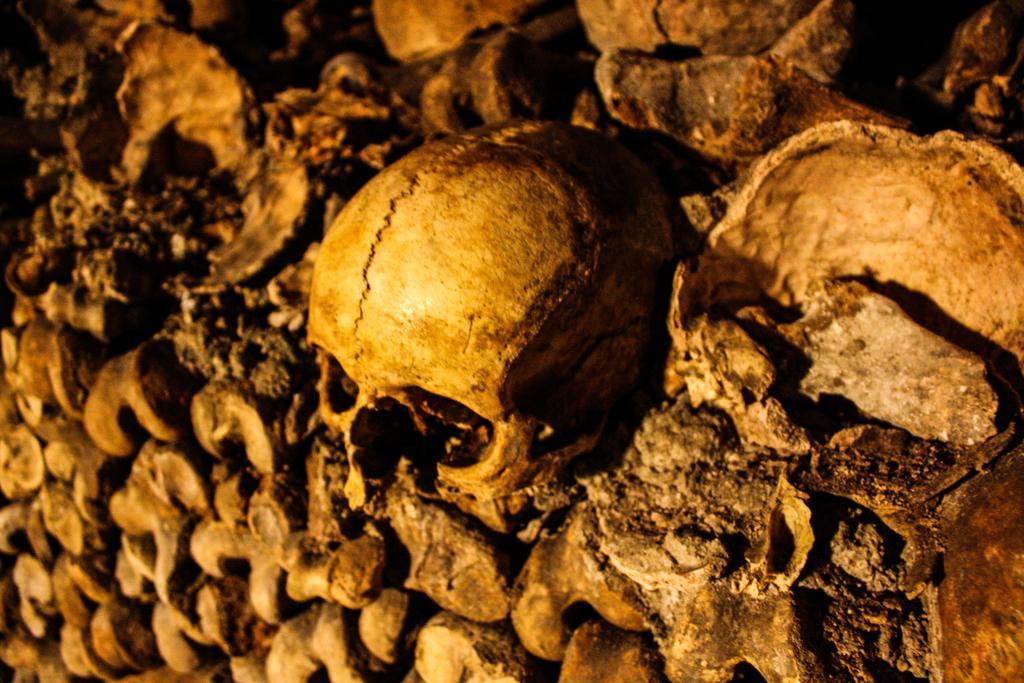Describe this image in one or two sentences. In the picture there are skulls and bones present. 